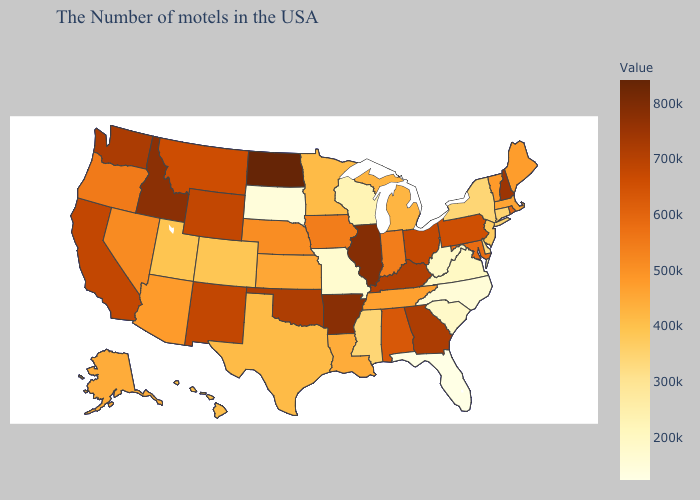Does North Dakota have the highest value in the USA?
Write a very short answer. Yes. Among the states that border Pennsylvania , which have the lowest value?
Be succinct. West Virginia. Which states have the highest value in the USA?
Be succinct. North Dakota. Which states have the highest value in the USA?
Be succinct. North Dakota. Does Idaho have the highest value in the West?
Be succinct. Yes. Which states have the lowest value in the USA?
Be succinct. Florida. Among the states that border Kentucky , does Missouri have the lowest value?
Short answer required. Yes. 